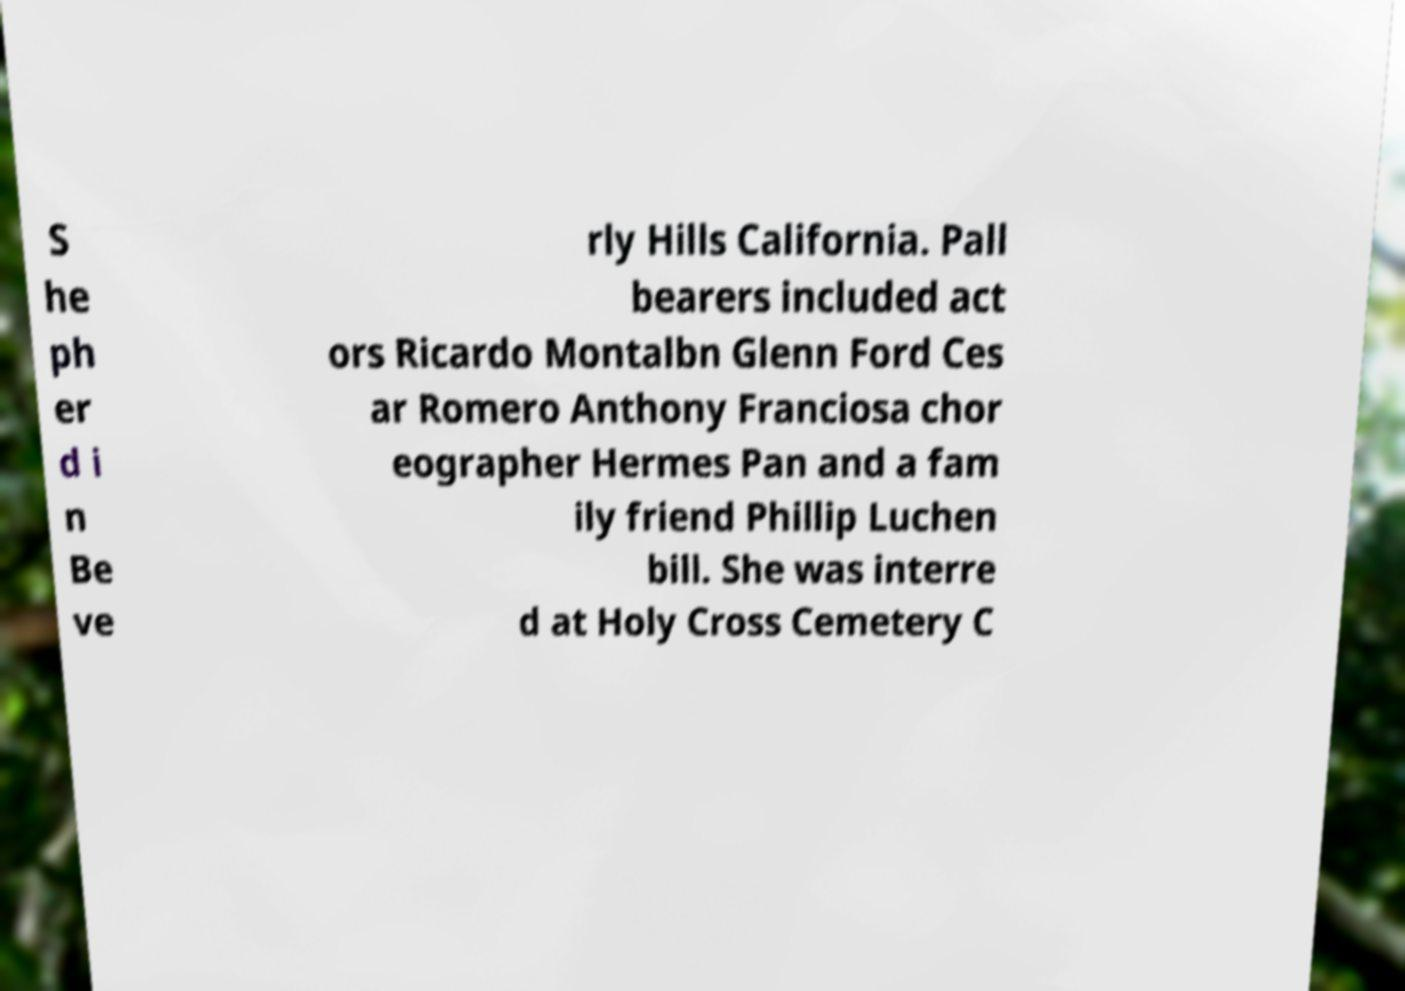Please identify and transcribe the text found in this image. S he ph er d i n Be ve rly Hills California. Pall bearers included act ors Ricardo Montalbn Glenn Ford Ces ar Romero Anthony Franciosa chor eographer Hermes Pan and a fam ily friend Phillip Luchen bill. She was interre d at Holy Cross Cemetery C 